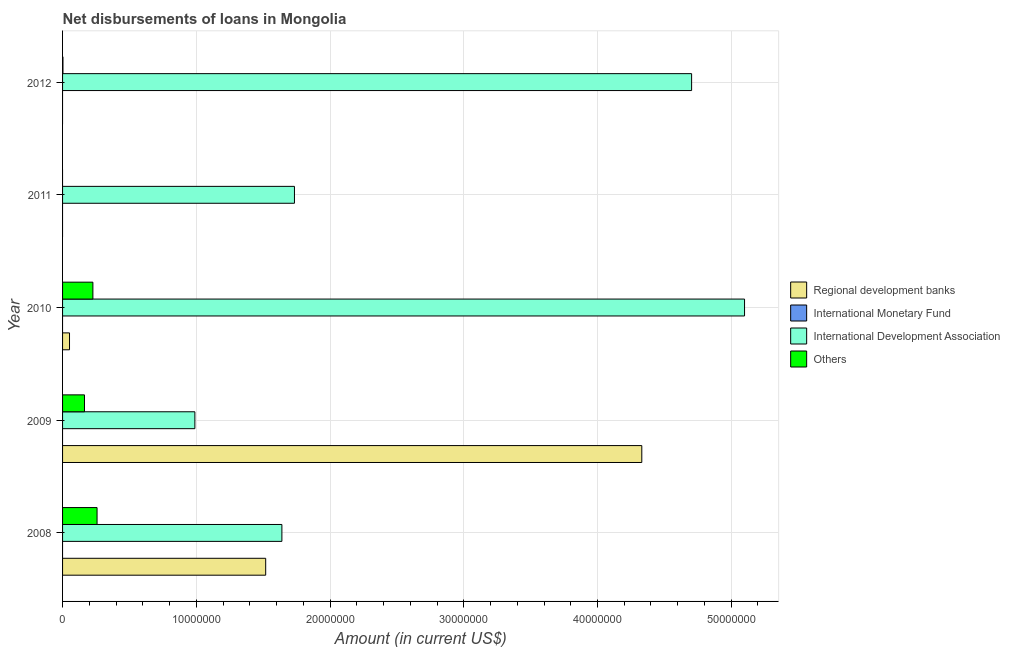What is the label of the 1st group of bars from the top?
Your answer should be very brief. 2012. In how many cases, is the number of bars for a given year not equal to the number of legend labels?
Provide a short and direct response. 5. What is the amount of loan disimbursed by international development association in 2012?
Make the answer very short. 4.70e+07. Across all years, what is the maximum amount of loan disimbursed by other organisations?
Your answer should be compact. 2.58e+06. Across all years, what is the minimum amount of loan disimbursed by international development association?
Your answer should be compact. 9.89e+06. What is the total amount of loan disimbursed by regional development banks in the graph?
Ensure brevity in your answer.  5.90e+07. What is the difference between the amount of loan disimbursed by international development association in 2009 and that in 2010?
Your response must be concise. -4.11e+07. What is the difference between the amount of loan disimbursed by international development association in 2010 and the amount of loan disimbursed by other organisations in 2008?
Give a very brief answer. 4.84e+07. What is the average amount of loan disimbursed by international development association per year?
Give a very brief answer. 2.83e+07. In the year 2009, what is the difference between the amount of loan disimbursed by regional development banks and amount of loan disimbursed by international development association?
Provide a short and direct response. 3.34e+07. In how many years, is the amount of loan disimbursed by other organisations greater than 38000000 US$?
Give a very brief answer. 0. What is the ratio of the amount of loan disimbursed by other organisations in 2008 to that in 2009?
Your answer should be compact. 1.57. Is the amount of loan disimbursed by other organisations in 2008 less than that in 2010?
Ensure brevity in your answer.  No. What is the difference between the highest and the second highest amount of loan disimbursed by other organisations?
Keep it short and to the point. 3.11e+05. What is the difference between the highest and the lowest amount of loan disimbursed by regional development banks?
Provide a short and direct response. 4.33e+07. In how many years, is the amount of loan disimbursed by international development association greater than the average amount of loan disimbursed by international development association taken over all years?
Give a very brief answer. 2. Is it the case that in every year, the sum of the amount of loan disimbursed by regional development banks and amount of loan disimbursed by international monetary fund is greater than the amount of loan disimbursed by international development association?
Offer a terse response. No. How many bars are there?
Offer a very short reply. 12. How many years are there in the graph?
Ensure brevity in your answer.  5. Does the graph contain any zero values?
Give a very brief answer. Yes. Where does the legend appear in the graph?
Your response must be concise. Center right. How many legend labels are there?
Give a very brief answer. 4. What is the title of the graph?
Make the answer very short. Net disbursements of loans in Mongolia. Does "UNHCR" appear as one of the legend labels in the graph?
Your answer should be very brief. No. What is the label or title of the X-axis?
Your response must be concise. Amount (in current US$). What is the label or title of the Y-axis?
Your answer should be very brief. Year. What is the Amount (in current US$) of Regional development banks in 2008?
Give a very brief answer. 1.52e+07. What is the Amount (in current US$) of International Development Association in 2008?
Offer a terse response. 1.64e+07. What is the Amount (in current US$) of Others in 2008?
Provide a succinct answer. 2.58e+06. What is the Amount (in current US$) of Regional development banks in 2009?
Make the answer very short. 4.33e+07. What is the Amount (in current US$) in International Monetary Fund in 2009?
Make the answer very short. 0. What is the Amount (in current US$) of International Development Association in 2009?
Your answer should be compact. 9.89e+06. What is the Amount (in current US$) in Others in 2009?
Offer a very short reply. 1.64e+06. What is the Amount (in current US$) in Regional development banks in 2010?
Your answer should be very brief. 5.20e+05. What is the Amount (in current US$) of International Development Association in 2010?
Offer a very short reply. 5.10e+07. What is the Amount (in current US$) in Others in 2010?
Provide a succinct answer. 2.27e+06. What is the Amount (in current US$) in International Development Association in 2011?
Your answer should be very brief. 1.73e+07. What is the Amount (in current US$) of Others in 2011?
Provide a short and direct response. 0. What is the Amount (in current US$) of International Development Association in 2012?
Offer a very short reply. 4.70e+07. What is the Amount (in current US$) of Others in 2012?
Offer a very short reply. 2.90e+04. Across all years, what is the maximum Amount (in current US$) of Regional development banks?
Your answer should be very brief. 4.33e+07. Across all years, what is the maximum Amount (in current US$) in International Development Association?
Make the answer very short. 5.10e+07. Across all years, what is the maximum Amount (in current US$) in Others?
Provide a succinct answer. 2.58e+06. Across all years, what is the minimum Amount (in current US$) in Regional development banks?
Keep it short and to the point. 0. Across all years, what is the minimum Amount (in current US$) in International Development Association?
Your answer should be compact. 9.89e+06. Across all years, what is the minimum Amount (in current US$) in Others?
Give a very brief answer. 0. What is the total Amount (in current US$) of Regional development banks in the graph?
Ensure brevity in your answer.  5.90e+07. What is the total Amount (in current US$) of International Monetary Fund in the graph?
Offer a very short reply. 0. What is the total Amount (in current US$) of International Development Association in the graph?
Your answer should be very brief. 1.42e+08. What is the total Amount (in current US$) of Others in the graph?
Make the answer very short. 6.52e+06. What is the difference between the Amount (in current US$) of Regional development banks in 2008 and that in 2009?
Your answer should be compact. -2.81e+07. What is the difference between the Amount (in current US$) of International Development Association in 2008 and that in 2009?
Make the answer very short. 6.51e+06. What is the difference between the Amount (in current US$) of Others in 2008 and that in 2009?
Ensure brevity in your answer.  9.40e+05. What is the difference between the Amount (in current US$) in Regional development banks in 2008 and that in 2010?
Your answer should be compact. 1.47e+07. What is the difference between the Amount (in current US$) in International Development Association in 2008 and that in 2010?
Offer a very short reply. -3.46e+07. What is the difference between the Amount (in current US$) in Others in 2008 and that in 2010?
Offer a terse response. 3.11e+05. What is the difference between the Amount (in current US$) of International Development Association in 2008 and that in 2011?
Provide a short and direct response. -9.40e+05. What is the difference between the Amount (in current US$) of International Development Association in 2008 and that in 2012?
Offer a very short reply. -3.06e+07. What is the difference between the Amount (in current US$) of Others in 2008 and that in 2012?
Ensure brevity in your answer.  2.55e+06. What is the difference between the Amount (in current US$) of Regional development banks in 2009 and that in 2010?
Give a very brief answer. 4.28e+07. What is the difference between the Amount (in current US$) in International Development Association in 2009 and that in 2010?
Offer a very short reply. -4.11e+07. What is the difference between the Amount (in current US$) of Others in 2009 and that in 2010?
Keep it short and to the point. -6.29e+05. What is the difference between the Amount (in current US$) of International Development Association in 2009 and that in 2011?
Give a very brief answer. -7.45e+06. What is the difference between the Amount (in current US$) in International Development Association in 2009 and that in 2012?
Offer a very short reply. -3.71e+07. What is the difference between the Amount (in current US$) in Others in 2009 and that in 2012?
Provide a succinct answer. 1.61e+06. What is the difference between the Amount (in current US$) in International Development Association in 2010 and that in 2011?
Your response must be concise. 3.37e+07. What is the difference between the Amount (in current US$) in International Development Association in 2010 and that in 2012?
Keep it short and to the point. 3.96e+06. What is the difference between the Amount (in current US$) in Others in 2010 and that in 2012?
Offer a very short reply. 2.24e+06. What is the difference between the Amount (in current US$) in International Development Association in 2011 and that in 2012?
Provide a short and direct response. -2.97e+07. What is the difference between the Amount (in current US$) in Regional development banks in 2008 and the Amount (in current US$) in International Development Association in 2009?
Give a very brief answer. 5.30e+06. What is the difference between the Amount (in current US$) in Regional development banks in 2008 and the Amount (in current US$) in Others in 2009?
Make the answer very short. 1.36e+07. What is the difference between the Amount (in current US$) in International Development Association in 2008 and the Amount (in current US$) in Others in 2009?
Your response must be concise. 1.48e+07. What is the difference between the Amount (in current US$) of Regional development banks in 2008 and the Amount (in current US$) of International Development Association in 2010?
Provide a succinct answer. -3.58e+07. What is the difference between the Amount (in current US$) in Regional development banks in 2008 and the Amount (in current US$) in Others in 2010?
Offer a very short reply. 1.29e+07. What is the difference between the Amount (in current US$) in International Development Association in 2008 and the Amount (in current US$) in Others in 2010?
Ensure brevity in your answer.  1.41e+07. What is the difference between the Amount (in current US$) of Regional development banks in 2008 and the Amount (in current US$) of International Development Association in 2011?
Ensure brevity in your answer.  -2.15e+06. What is the difference between the Amount (in current US$) in Regional development banks in 2008 and the Amount (in current US$) in International Development Association in 2012?
Your answer should be compact. -3.18e+07. What is the difference between the Amount (in current US$) in Regional development banks in 2008 and the Amount (in current US$) in Others in 2012?
Your answer should be very brief. 1.52e+07. What is the difference between the Amount (in current US$) in International Development Association in 2008 and the Amount (in current US$) in Others in 2012?
Provide a succinct answer. 1.64e+07. What is the difference between the Amount (in current US$) in Regional development banks in 2009 and the Amount (in current US$) in International Development Association in 2010?
Offer a very short reply. -7.68e+06. What is the difference between the Amount (in current US$) of Regional development banks in 2009 and the Amount (in current US$) of Others in 2010?
Keep it short and to the point. 4.10e+07. What is the difference between the Amount (in current US$) of International Development Association in 2009 and the Amount (in current US$) of Others in 2010?
Give a very brief answer. 7.62e+06. What is the difference between the Amount (in current US$) in Regional development banks in 2009 and the Amount (in current US$) in International Development Association in 2011?
Provide a succinct answer. 2.60e+07. What is the difference between the Amount (in current US$) of Regional development banks in 2009 and the Amount (in current US$) of International Development Association in 2012?
Ensure brevity in your answer.  -3.72e+06. What is the difference between the Amount (in current US$) of Regional development banks in 2009 and the Amount (in current US$) of Others in 2012?
Ensure brevity in your answer.  4.33e+07. What is the difference between the Amount (in current US$) in International Development Association in 2009 and the Amount (in current US$) in Others in 2012?
Offer a terse response. 9.86e+06. What is the difference between the Amount (in current US$) in Regional development banks in 2010 and the Amount (in current US$) in International Development Association in 2011?
Give a very brief answer. -1.68e+07. What is the difference between the Amount (in current US$) of Regional development banks in 2010 and the Amount (in current US$) of International Development Association in 2012?
Offer a very short reply. -4.65e+07. What is the difference between the Amount (in current US$) in Regional development banks in 2010 and the Amount (in current US$) in Others in 2012?
Your answer should be compact. 4.91e+05. What is the difference between the Amount (in current US$) of International Development Association in 2010 and the Amount (in current US$) of Others in 2012?
Make the answer very short. 5.10e+07. What is the difference between the Amount (in current US$) in International Development Association in 2011 and the Amount (in current US$) in Others in 2012?
Your answer should be very brief. 1.73e+07. What is the average Amount (in current US$) of Regional development banks per year?
Provide a succinct answer. 1.18e+07. What is the average Amount (in current US$) of International Monetary Fund per year?
Ensure brevity in your answer.  0. What is the average Amount (in current US$) of International Development Association per year?
Make the answer very short. 2.83e+07. What is the average Amount (in current US$) in Others per year?
Provide a short and direct response. 1.30e+06. In the year 2008, what is the difference between the Amount (in current US$) in Regional development banks and Amount (in current US$) in International Development Association?
Ensure brevity in your answer.  -1.21e+06. In the year 2008, what is the difference between the Amount (in current US$) of Regional development banks and Amount (in current US$) of Others?
Offer a very short reply. 1.26e+07. In the year 2008, what is the difference between the Amount (in current US$) in International Development Association and Amount (in current US$) in Others?
Provide a short and direct response. 1.38e+07. In the year 2009, what is the difference between the Amount (in current US$) of Regional development banks and Amount (in current US$) of International Development Association?
Provide a short and direct response. 3.34e+07. In the year 2009, what is the difference between the Amount (in current US$) of Regional development banks and Amount (in current US$) of Others?
Make the answer very short. 4.17e+07. In the year 2009, what is the difference between the Amount (in current US$) in International Development Association and Amount (in current US$) in Others?
Ensure brevity in your answer.  8.25e+06. In the year 2010, what is the difference between the Amount (in current US$) in Regional development banks and Amount (in current US$) in International Development Association?
Offer a very short reply. -5.05e+07. In the year 2010, what is the difference between the Amount (in current US$) of Regional development banks and Amount (in current US$) of Others?
Provide a short and direct response. -1.75e+06. In the year 2010, what is the difference between the Amount (in current US$) in International Development Association and Amount (in current US$) in Others?
Your answer should be very brief. 4.87e+07. In the year 2012, what is the difference between the Amount (in current US$) in International Development Association and Amount (in current US$) in Others?
Offer a terse response. 4.70e+07. What is the ratio of the Amount (in current US$) in Regional development banks in 2008 to that in 2009?
Your response must be concise. 0.35. What is the ratio of the Amount (in current US$) in International Development Association in 2008 to that in 2009?
Give a very brief answer. 1.66. What is the ratio of the Amount (in current US$) in Others in 2008 to that in 2009?
Offer a very short reply. 1.57. What is the ratio of the Amount (in current US$) in Regional development banks in 2008 to that in 2010?
Your answer should be very brief. 29.21. What is the ratio of the Amount (in current US$) of International Development Association in 2008 to that in 2010?
Offer a very short reply. 0.32. What is the ratio of the Amount (in current US$) in Others in 2008 to that in 2010?
Give a very brief answer. 1.14. What is the ratio of the Amount (in current US$) in International Development Association in 2008 to that in 2011?
Provide a succinct answer. 0.95. What is the ratio of the Amount (in current US$) of International Development Association in 2008 to that in 2012?
Provide a short and direct response. 0.35. What is the ratio of the Amount (in current US$) of Others in 2008 to that in 2012?
Offer a terse response. 88.93. What is the ratio of the Amount (in current US$) of Regional development banks in 2009 to that in 2010?
Keep it short and to the point. 83.29. What is the ratio of the Amount (in current US$) of International Development Association in 2009 to that in 2010?
Ensure brevity in your answer.  0.19. What is the ratio of the Amount (in current US$) in Others in 2009 to that in 2010?
Make the answer very short. 0.72. What is the ratio of the Amount (in current US$) in International Development Association in 2009 to that in 2011?
Offer a very short reply. 0.57. What is the ratio of the Amount (in current US$) of International Development Association in 2009 to that in 2012?
Offer a terse response. 0.21. What is the ratio of the Amount (in current US$) of Others in 2009 to that in 2012?
Your response must be concise. 56.52. What is the ratio of the Amount (in current US$) in International Development Association in 2010 to that in 2011?
Provide a short and direct response. 2.94. What is the ratio of the Amount (in current US$) of International Development Association in 2010 to that in 2012?
Make the answer very short. 1.08. What is the ratio of the Amount (in current US$) of Others in 2010 to that in 2012?
Ensure brevity in your answer.  78.21. What is the ratio of the Amount (in current US$) of International Development Association in 2011 to that in 2012?
Keep it short and to the point. 0.37. What is the difference between the highest and the second highest Amount (in current US$) in Regional development banks?
Provide a succinct answer. 2.81e+07. What is the difference between the highest and the second highest Amount (in current US$) in International Development Association?
Offer a terse response. 3.96e+06. What is the difference between the highest and the second highest Amount (in current US$) in Others?
Keep it short and to the point. 3.11e+05. What is the difference between the highest and the lowest Amount (in current US$) in Regional development banks?
Provide a short and direct response. 4.33e+07. What is the difference between the highest and the lowest Amount (in current US$) of International Development Association?
Offer a very short reply. 4.11e+07. What is the difference between the highest and the lowest Amount (in current US$) of Others?
Your answer should be very brief. 2.58e+06. 